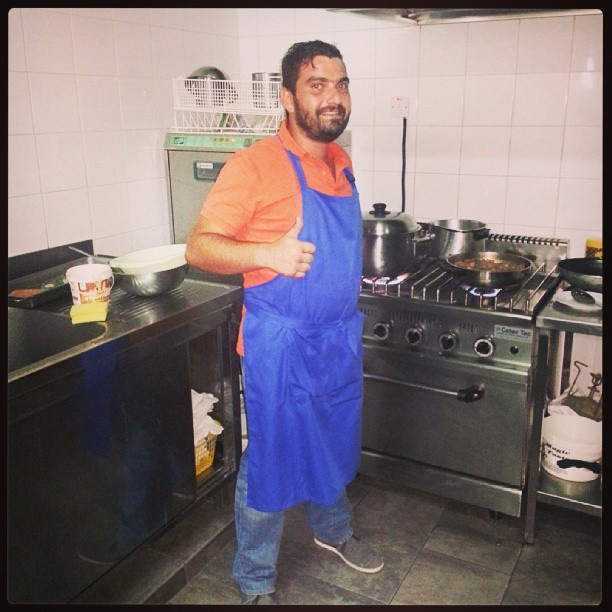Describe the objects in this image and their specific colors. I can see people in black, blue, salmon, and gray tones, oven in black and gray tones, refrigerator in black, darkgray, tan, beige, and gray tones, sink in black and gray tones, and bowl in black, ivory, beige, and tan tones in this image. 